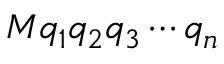<formula> <loc_0><loc_0><loc_500><loc_500>M q _ { 1 } q _ { 2 } q _ { 3 } \cdots q _ { n }</formula> 